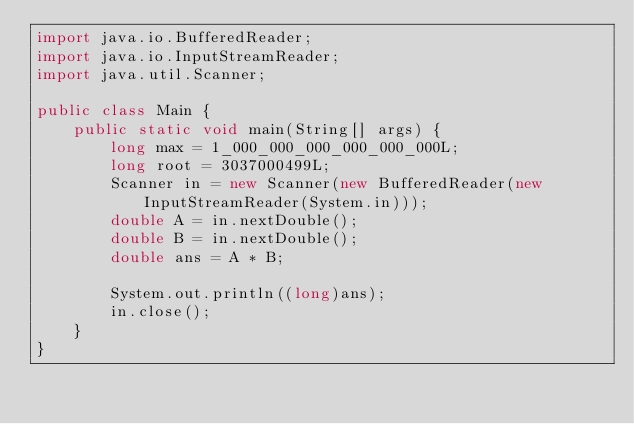<code> <loc_0><loc_0><loc_500><loc_500><_Java_>import java.io.BufferedReader;
import java.io.InputStreamReader;
import java.util.Scanner;

public class Main {
    public static void main(String[] args) {
        long max = 1_000_000_000_000_000_000L;
        long root = 3037000499L;
        Scanner in = new Scanner(new BufferedReader(new InputStreamReader(System.in)));
        double A = in.nextDouble();
        double B = in.nextDouble();
        double ans = A * B;

        System.out.println((long)ans);
        in.close();
    }
}</code> 